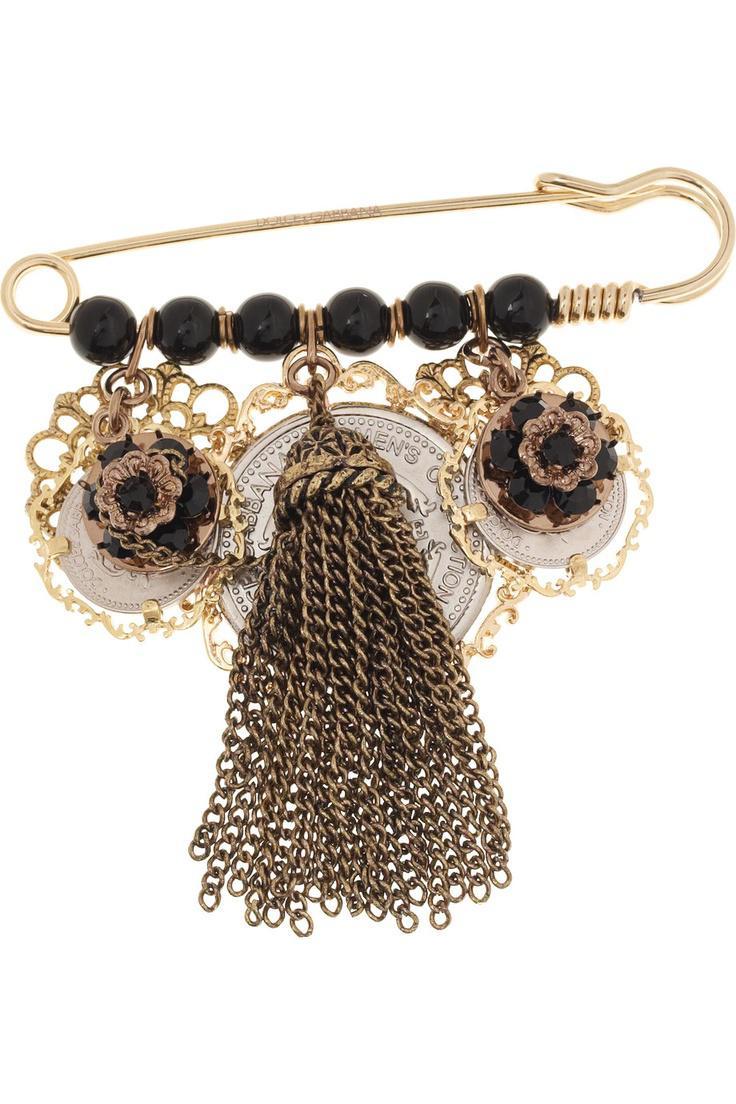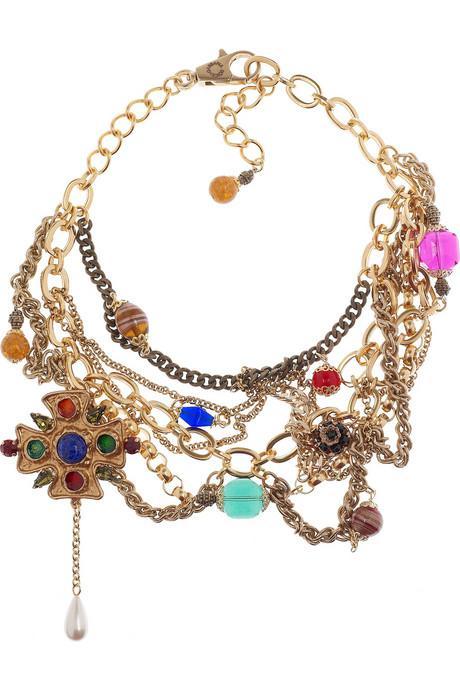The first image is the image on the left, the second image is the image on the right. Analyze the images presented: Is the assertion "A gold safety pin is strung with a row of six black beads and suspends a tassel made of chains." valid? Answer yes or no. Yes. The first image is the image on the left, the second image is the image on the right. Examine the images to the left and right. Is the description "There is a heart charm to the right of some other charms." accurate? Answer yes or no. No. 